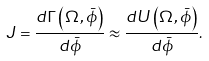<formula> <loc_0><loc_0><loc_500><loc_500>J = \frac { d \Gamma \left ( \Omega , \bar { \phi } \right ) } { d \bar { \phi } } \approx \frac { d U \left ( \Omega , \bar { \phi } \right ) } { d \bar { \phi } } .</formula> 